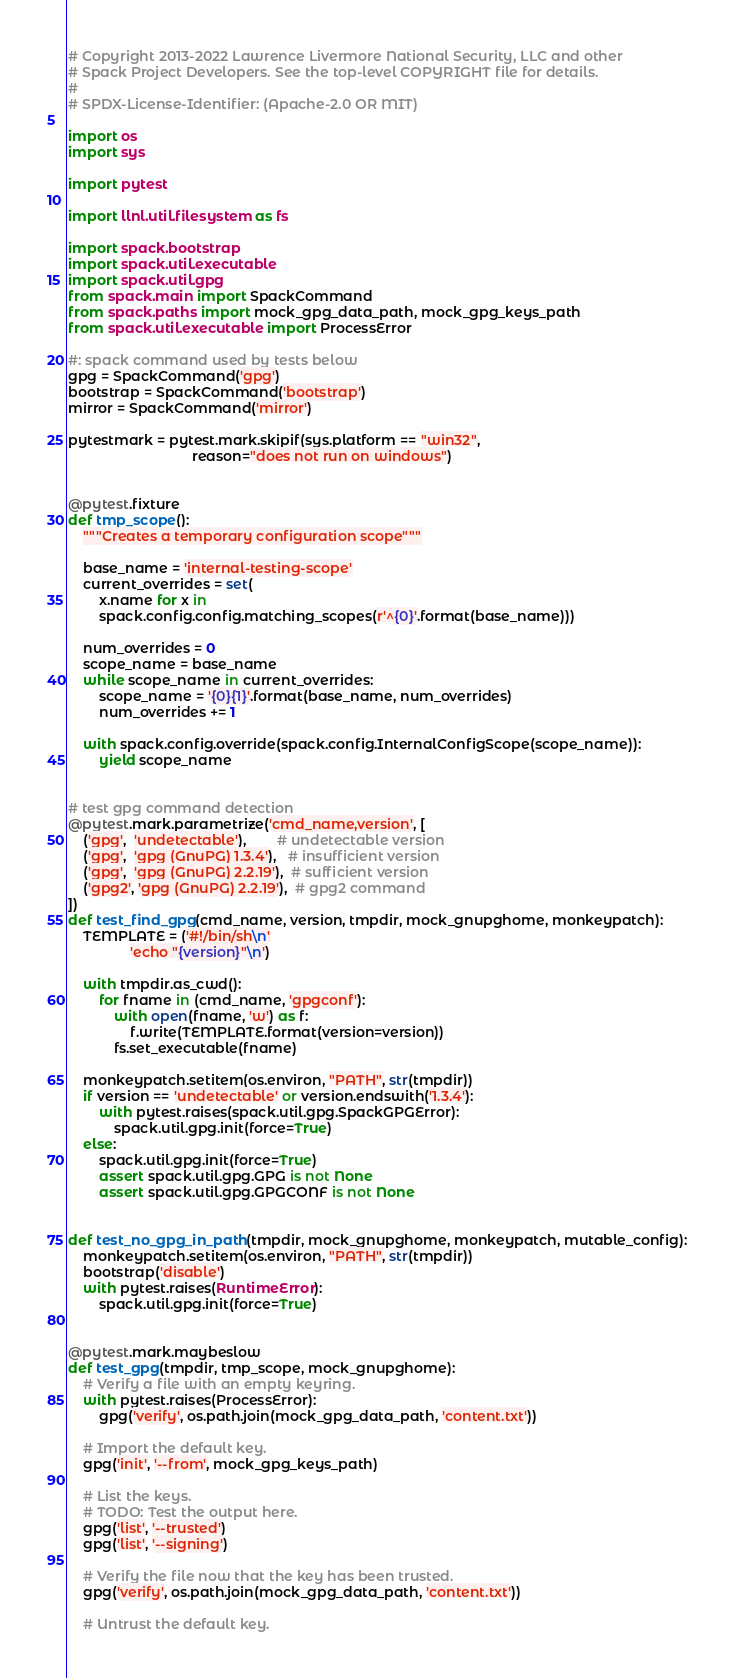<code> <loc_0><loc_0><loc_500><loc_500><_Python_># Copyright 2013-2022 Lawrence Livermore National Security, LLC and other
# Spack Project Developers. See the top-level COPYRIGHT file for details.
#
# SPDX-License-Identifier: (Apache-2.0 OR MIT)

import os
import sys

import pytest

import llnl.util.filesystem as fs

import spack.bootstrap
import spack.util.executable
import spack.util.gpg
from spack.main import SpackCommand
from spack.paths import mock_gpg_data_path, mock_gpg_keys_path
from spack.util.executable import ProcessError

#: spack command used by tests below
gpg = SpackCommand('gpg')
bootstrap = SpackCommand('bootstrap')
mirror = SpackCommand('mirror')

pytestmark = pytest.mark.skipif(sys.platform == "win32",
                                reason="does not run on windows")


@pytest.fixture
def tmp_scope():
    """Creates a temporary configuration scope"""

    base_name = 'internal-testing-scope'
    current_overrides = set(
        x.name for x in
        spack.config.config.matching_scopes(r'^{0}'.format(base_name)))

    num_overrides = 0
    scope_name = base_name
    while scope_name in current_overrides:
        scope_name = '{0}{1}'.format(base_name, num_overrides)
        num_overrides += 1

    with spack.config.override(spack.config.InternalConfigScope(scope_name)):
        yield scope_name


# test gpg command detection
@pytest.mark.parametrize('cmd_name,version', [
    ('gpg',  'undetectable'),        # undetectable version
    ('gpg',  'gpg (GnuPG) 1.3.4'),   # insufficient version
    ('gpg',  'gpg (GnuPG) 2.2.19'),  # sufficient version
    ('gpg2', 'gpg (GnuPG) 2.2.19'),  # gpg2 command
])
def test_find_gpg(cmd_name, version, tmpdir, mock_gnupghome, monkeypatch):
    TEMPLATE = ('#!/bin/sh\n'
                'echo "{version}"\n')

    with tmpdir.as_cwd():
        for fname in (cmd_name, 'gpgconf'):
            with open(fname, 'w') as f:
                f.write(TEMPLATE.format(version=version))
            fs.set_executable(fname)

    monkeypatch.setitem(os.environ, "PATH", str(tmpdir))
    if version == 'undetectable' or version.endswith('1.3.4'):
        with pytest.raises(spack.util.gpg.SpackGPGError):
            spack.util.gpg.init(force=True)
    else:
        spack.util.gpg.init(force=True)
        assert spack.util.gpg.GPG is not None
        assert spack.util.gpg.GPGCONF is not None


def test_no_gpg_in_path(tmpdir, mock_gnupghome, monkeypatch, mutable_config):
    monkeypatch.setitem(os.environ, "PATH", str(tmpdir))
    bootstrap('disable')
    with pytest.raises(RuntimeError):
        spack.util.gpg.init(force=True)


@pytest.mark.maybeslow
def test_gpg(tmpdir, tmp_scope, mock_gnupghome):
    # Verify a file with an empty keyring.
    with pytest.raises(ProcessError):
        gpg('verify', os.path.join(mock_gpg_data_path, 'content.txt'))

    # Import the default key.
    gpg('init', '--from', mock_gpg_keys_path)

    # List the keys.
    # TODO: Test the output here.
    gpg('list', '--trusted')
    gpg('list', '--signing')

    # Verify the file now that the key has been trusted.
    gpg('verify', os.path.join(mock_gpg_data_path, 'content.txt'))

    # Untrust the default key.</code> 